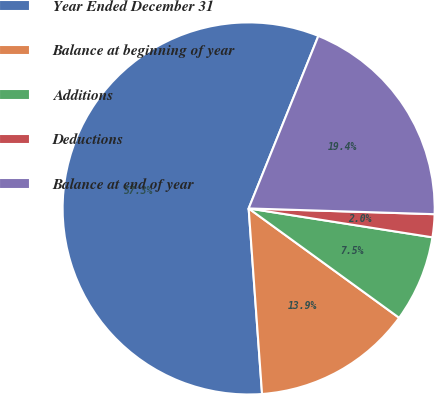<chart> <loc_0><loc_0><loc_500><loc_500><pie_chart><fcel>Year Ended December 31<fcel>Balance at beginning of year<fcel>Additions<fcel>Deductions<fcel>Balance at end of year<nl><fcel>57.26%<fcel>13.85%<fcel>7.52%<fcel>1.99%<fcel>19.38%<nl></chart> 